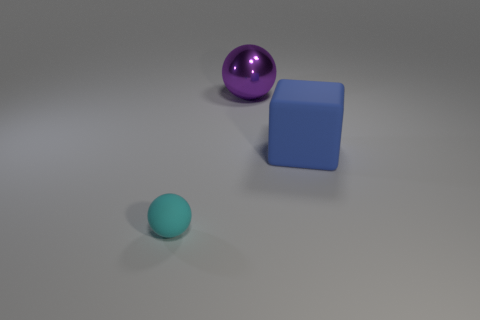How many things are things that are on the right side of the cyan rubber object or small cyan matte balls?
Provide a short and direct response. 3. Are there any small cyan rubber objects that have the same shape as the large purple metal object?
Ensure brevity in your answer.  Yes. Is the number of purple things to the right of the cyan matte thing the same as the number of large blue things?
Give a very brief answer. Yes. What number of rubber objects are the same size as the metallic sphere?
Your response must be concise. 1. What number of big balls are in front of the big matte thing?
Your answer should be compact. 0. There is a sphere that is behind the sphere that is on the left side of the large metallic thing; what is its material?
Offer a very short reply. Metal. There is another object that is made of the same material as the cyan object; what size is it?
Provide a short and direct response. Large. The sphere in front of the big purple thing is what color?
Make the answer very short. Cyan. Are there any metal balls on the right side of the sphere in front of the rubber object that is behind the small cyan ball?
Your answer should be very brief. Yes. Are there more big objects on the right side of the metal object than tiny green blocks?
Keep it short and to the point. Yes. 